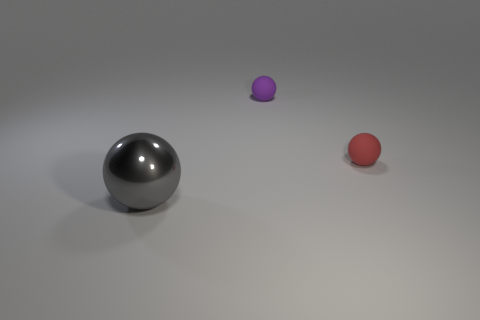Subtract all tiny spheres. How many spheres are left? 1 Add 1 big yellow spheres. How many objects exist? 4 Subtract all gray balls. How many balls are left? 2 Subtract 1 spheres. How many spheres are left? 2 Subtract 0 green cubes. How many objects are left? 3 Subtract all green spheres. Subtract all yellow cylinders. How many spheres are left? 3 Subtract all large objects. Subtract all big purple shiny things. How many objects are left? 2 Add 2 small red spheres. How many small red spheres are left? 3 Add 3 tiny green metallic cylinders. How many tiny green metallic cylinders exist? 3 